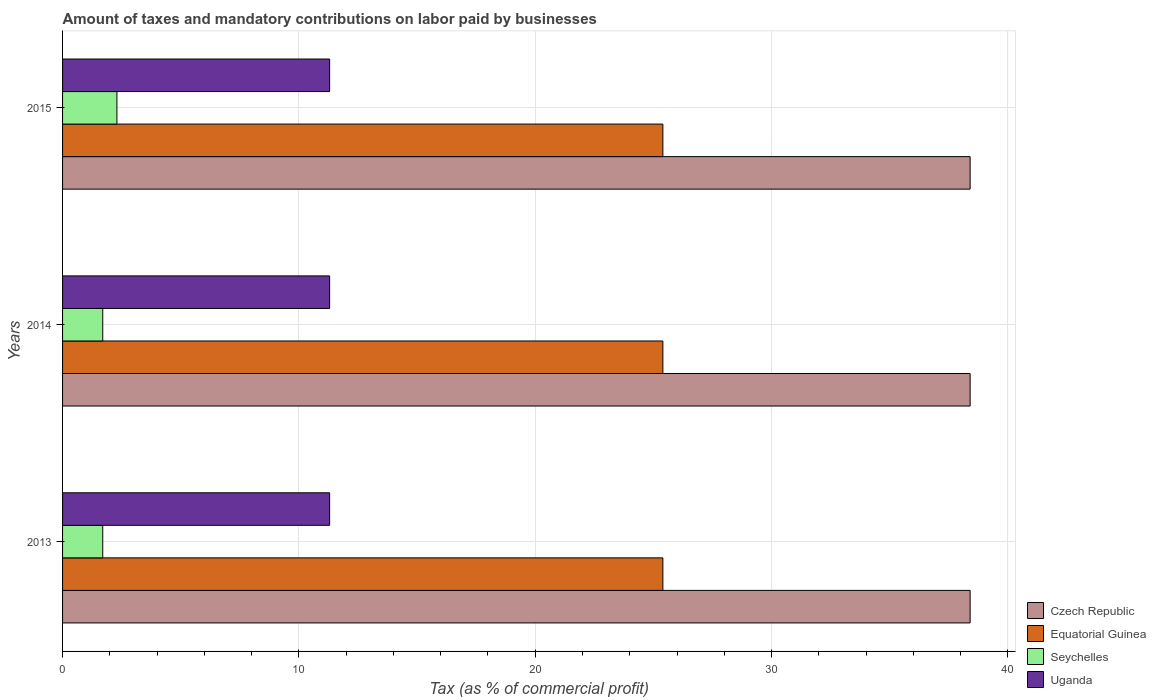How many different coloured bars are there?
Your answer should be compact. 4. Are the number of bars per tick equal to the number of legend labels?
Make the answer very short. Yes. In how many cases, is the number of bars for a given year not equal to the number of legend labels?
Provide a short and direct response. 0. What is the percentage of taxes paid by businesses in Czech Republic in 2014?
Offer a very short reply. 38.4. Across all years, what is the maximum percentage of taxes paid by businesses in Czech Republic?
Offer a terse response. 38.4. Across all years, what is the minimum percentage of taxes paid by businesses in Seychelles?
Offer a very short reply. 1.7. What is the total percentage of taxes paid by businesses in Seychelles in the graph?
Give a very brief answer. 5.7. What is the difference between the percentage of taxes paid by businesses in Uganda in 2013 and that in 2015?
Your answer should be compact. 0. What is the difference between the percentage of taxes paid by businesses in Seychelles in 2013 and the percentage of taxes paid by businesses in Uganda in 2015?
Your answer should be very brief. -9.6. What is the average percentage of taxes paid by businesses in Seychelles per year?
Keep it short and to the point. 1.9. In the year 2015, what is the difference between the percentage of taxes paid by businesses in Seychelles and percentage of taxes paid by businesses in Czech Republic?
Your answer should be very brief. -36.1. What is the ratio of the percentage of taxes paid by businesses in Equatorial Guinea in 2014 to that in 2015?
Offer a very short reply. 1. What is the difference between the highest and the lowest percentage of taxes paid by businesses in Uganda?
Keep it short and to the point. 0. Is the sum of the percentage of taxes paid by businesses in Equatorial Guinea in 2013 and 2014 greater than the maximum percentage of taxes paid by businesses in Czech Republic across all years?
Offer a very short reply. Yes. Is it the case that in every year, the sum of the percentage of taxes paid by businesses in Equatorial Guinea and percentage of taxes paid by businesses in Uganda is greater than the sum of percentage of taxes paid by businesses in Seychelles and percentage of taxes paid by businesses in Czech Republic?
Your answer should be very brief. No. What does the 4th bar from the top in 2015 represents?
Provide a short and direct response. Czech Republic. What does the 1st bar from the bottom in 2015 represents?
Your answer should be compact. Czech Republic. Is it the case that in every year, the sum of the percentage of taxes paid by businesses in Uganda and percentage of taxes paid by businesses in Equatorial Guinea is greater than the percentage of taxes paid by businesses in Czech Republic?
Keep it short and to the point. No. Are all the bars in the graph horizontal?
Your answer should be very brief. Yes. How many years are there in the graph?
Give a very brief answer. 3. Are the values on the major ticks of X-axis written in scientific E-notation?
Keep it short and to the point. No. How many legend labels are there?
Give a very brief answer. 4. How are the legend labels stacked?
Provide a short and direct response. Vertical. What is the title of the graph?
Provide a short and direct response. Amount of taxes and mandatory contributions on labor paid by businesses. Does "Upper middle income" appear as one of the legend labels in the graph?
Offer a very short reply. No. What is the label or title of the X-axis?
Provide a succinct answer. Tax (as % of commercial profit). What is the Tax (as % of commercial profit) of Czech Republic in 2013?
Provide a short and direct response. 38.4. What is the Tax (as % of commercial profit) of Equatorial Guinea in 2013?
Ensure brevity in your answer.  25.4. What is the Tax (as % of commercial profit) in Uganda in 2013?
Offer a very short reply. 11.3. What is the Tax (as % of commercial profit) of Czech Republic in 2014?
Provide a succinct answer. 38.4. What is the Tax (as % of commercial profit) of Equatorial Guinea in 2014?
Your answer should be compact. 25.4. What is the Tax (as % of commercial profit) of Seychelles in 2014?
Your answer should be compact. 1.7. What is the Tax (as % of commercial profit) of Czech Republic in 2015?
Offer a terse response. 38.4. What is the Tax (as % of commercial profit) in Equatorial Guinea in 2015?
Provide a short and direct response. 25.4. What is the Tax (as % of commercial profit) in Seychelles in 2015?
Keep it short and to the point. 2.3. Across all years, what is the maximum Tax (as % of commercial profit) in Czech Republic?
Ensure brevity in your answer.  38.4. Across all years, what is the maximum Tax (as % of commercial profit) of Equatorial Guinea?
Provide a succinct answer. 25.4. Across all years, what is the minimum Tax (as % of commercial profit) in Czech Republic?
Your answer should be very brief. 38.4. Across all years, what is the minimum Tax (as % of commercial profit) in Equatorial Guinea?
Provide a succinct answer. 25.4. Across all years, what is the minimum Tax (as % of commercial profit) in Uganda?
Your response must be concise. 11.3. What is the total Tax (as % of commercial profit) of Czech Republic in the graph?
Make the answer very short. 115.2. What is the total Tax (as % of commercial profit) in Equatorial Guinea in the graph?
Ensure brevity in your answer.  76.2. What is the total Tax (as % of commercial profit) of Seychelles in the graph?
Provide a short and direct response. 5.7. What is the total Tax (as % of commercial profit) of Uganda in the graph?
Provide a succinct answer. 33.9. What is the difference between the Tax (as % of commercial profit) in Czech Republic in 2013 and that in 2014?
Provide a succinct answer. 0. What is the difference between the Tax (as % of commercial profit) of Equatorial Guinea in 2013 and that in 2014?
Your response must be concise. 0. What is the difference between the Tax (as % of commercial profit) in Seychelles in 2013 and that in 2015?
Provide a short and direct response. -0.6. What is the difference between the Tax (as % of commercial profit) in Czech Republic in 2014 and that in 2015?
Provide a succinct answer. 0. What is the difference between the Tax (as % of commercial profit) in Equatorial Guinea in 2014 and that in 2015?
Provide a succinct answer. 0. What is the difference between the Tax (as % of commercial profit) in Seychelles in 2014 and that in 2015?
Give a very brief answer. -0.6. What is the difference between the Tax (as % of commercial profit) in Uganda in 2014 and that in 2015?
Your answer should be compact. 0. What is the difference between the Tax (as % of commercial profit) in Czech Republic in 2013 and the Tax (as % of commercial profit) in Equatorial Guinea in 2014?
Offer a very short reply. 13. What is the difference between the Tax (as % of commercial profit) in Czech Republic in 2013 and the Tax (as % of commercial profit) in Seychelles in 2014?
Your answer should be compact. 36.7. What is the difference between the Tax (as % of commercial profit) in Czech Republic in 2013 and the Tax (as % of commercial profit) in Uganda in 2014?
Give a very brief answer. 27.1. What is the difference between the Tax (as % of commercial profit) of Equatorial Guinea in 2013 and the Tax (as % of commercial profit) of Seychelles in 2014?
Your answer should be compact. 23.7. What is the difference between the Tax (as % of commercial profit) in Equatorial Guinea in 2013 and the Tax (as % of commercial profit) in Uganda in 2014?
Make the answer very short. 14.1. What is the difference between the Tax (as % of commercial profit) of Czech Republic in 2013 and the Tax (as % of commercial profit) of Seychelles in 2015?
Your response must be concise. 36.1. What is the difference between the Tax (as % of commercial profit) of Czech Republic in 2013 and the Tax (as % of commercial profit) of Uganda in 2015?
Provide a short and direct response. 27.1. What is the difference between the Tax (as % of commercial profit) of Equatorial Guinea in 2013 and the Tax (as % of commercial profit) of Seychelles in 2015?
Ensure brevity in your answer.  23.1. What is the difference between the Tax (as % of commercial profit) of Equatorial Guinea in 2013 and the Tax (as % of commercial profit) of Uganda in 2015?
Provide a short and direct response. 14.1. What is the difference between the Tax (as % of commercial profit) in Czech Republic in 2014 and the Tax (as % of commercial profit) in Equatorial Guinea in 2015?
Provide a succinct answer. 13. What is the difference between the Tax (as % of commercial profit) in Czech Republic in 2014 and the Tax (as % of commercial profit) in Seychelles in 2015?
Make the answer very short. 36.1. What is the difference between the Tax (as % of commercial profit) of Czech Republic in 2014 and the Tax (as % of commercial profit) of Uganda in 2015?
Make the answer very short. 27.1. What is the difference between the Tax (as % of commercial profit) of Equatorial Guinea in 2014 and the Tax (as % of commercial profit) of Seychelles in 2015?
Make the answer very short. 23.1. What is the average Tax (as % of commercial profit) of Czech Republic per year?
Provide a short and direct response. 38.4. What is the average Tax (as % of commercial profit) in Equatorial Guinea per year?
Provide a short and direct response. 25.4. What is the average Tax (as % of commercial profit) of Seychelles per year?
Make the answer very short. 1.9. What is the average Tax (as % of commercial profit) of Uganda per year?
Give a very brief answer. 11.3. In the year 2013, what is the difference between the Tax (as % of commercial profit) of Czech Republic and Tax (as % of commercial profit) of Seychelles?
Provide a succinct answer. 36.7. In the year 2013, what is the difference between the Tax (as % of commercial profit) in Czech Republic and Tax (as % of commercial profit) in Uganda?
Keep it short and to the point. 27.1. In the year 2013, what is the difference between the Tax (as % of commercial profit) of Equatorial Guinea and Tax (as % of commercial profit) of Seychelles?
Your answer should be very brief. 23.7. In the year 2013, what is the difference between the Tax (as % of commercial profit) in Seychelles and Tax (as % of commercial profit) in Uganda?
Your answer should be compact. -9.6. In the year 2014, what is the difference between the Tax (as % of commercial profit) in Czech Republic and Tax (as % of commercial profit) in Equatorial Guinea?
Offer a very short reply. 13. In the year 2014, what is the difference between the Tax (as % of commercial profit) of Czech Republic and Tax (as % of commercial profit) of Seychelles?
Your response must be concise. 36.7. In the year 2014, what is the difference between the Tax (as % of commercial profit) of Czech Republic and Tax (as % of commercial profit) of Uganda?
Offer a terse response. 27.1. In the year 2014, what is the difference between the Tax (as % of commercial profit) in Equatorial Guinea and Tax (as % of commercial profit) in Seychelles?
Your answer should be very brief. 23.7. In the year 2014, what is the difference between the Tax (as % of commercial profit) in Seychelles and Tax (as % of commercial profit) in Uganda?
Your answer should be very brief. -9.6. In the year 2015, what is the difference between the Tax (as % of commercial profit) of Czech Republic and Tax (as % of commercial profit) of Seychelles?
Ensure brevity in your answer.  36.1. In the year 2015, what is the difference between the Tax (as % of commercial profit) in Czech Republic and Tax (as % of commercial profit) in Uganda?
Keep it short and to the point. 27.1. In the year 2015, what is the difference between the Tax (as % of commercial profit) of Equatorial Guinea and Tax (as % of commercial profit) of Seychelles?
Give a very brief answer. 23.1. What is the ratio of the Tax (as % of commercial profit) of Equatorial Guinea in 2013 to that in 2014?
Provide a short and direct response. 1. What is the ratio of the Tax (as % of commercial profit) of Seychelles in 2013 to that in 2015?
Your response must be concise. 0.74. What is the ratio of the Tax (as % of commercial profit) in Equatorial Guinea in 2014 to that in 2015?
Keep it short and to the point. 1. What is the ratio of the Tax (as % of commercial profit) in Seychelles in 2014 to that in 2015?
Make the answer very short. 0.74. What is the ratio of the Tax (as % of commercial profit) in Uganda in 2014 to that in 2015?
Make the answer very short. 1. What is the difference between the highest and the second highest Tax (as % of commercial profit) in Uganda?
Ensure brevity in your answer.  0. What is the difference between the highest and the lowest Tax (as % of commercial profit) in Czech Republic?
Your response must be concise. 0. What is the difference between the highest and the lowest Tax (as % of commercial profit) of Equatorial Guinea?
Ensure brevity in your answer.  0. What is the difference between the highest and the lowest Tax (as % of commercial profit) in Uganda?
Provide a short and direct response. 0. 